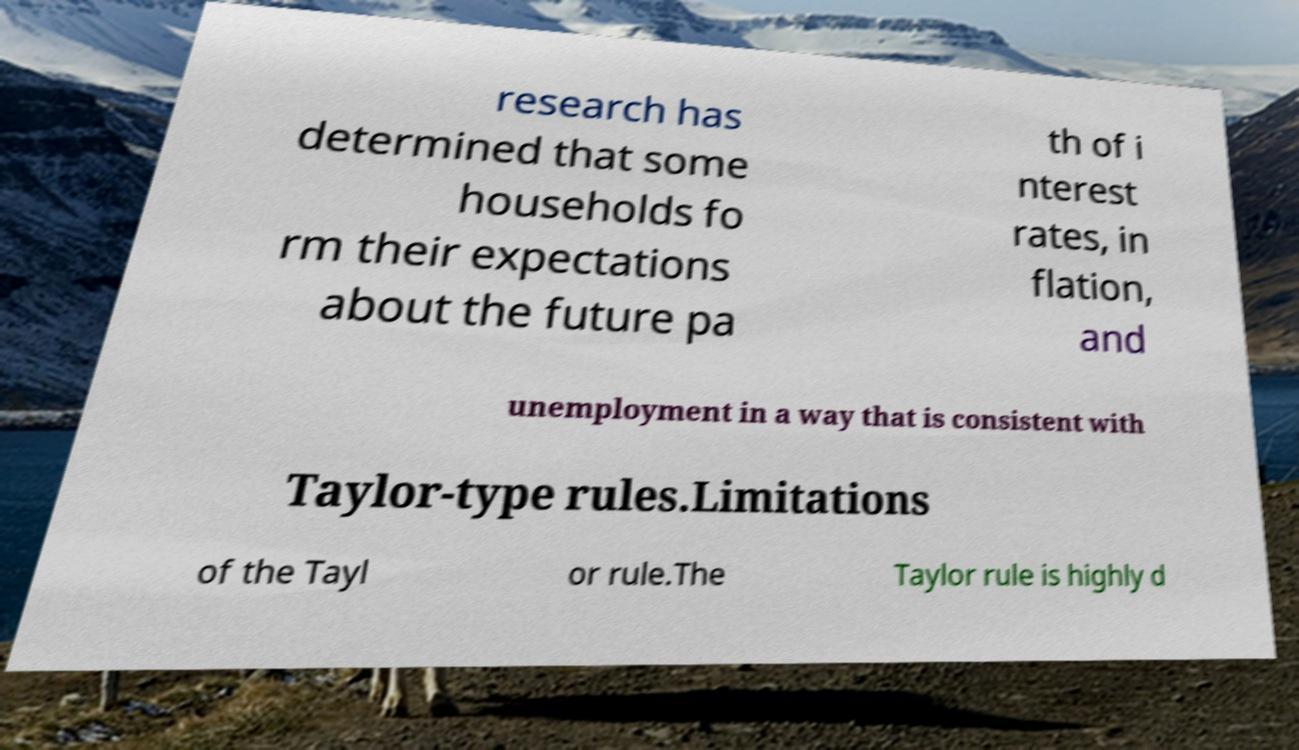What messages or text are displayed in this image? I need them in a readable, typed format. research has determined that some households fo rm their expectations about the future pa th of i nterest rates, in flation, and unemployment in a way that is consistent with Taylor-type rules.Limitations of the Tayl or rule.The Taylor rule is highly d 